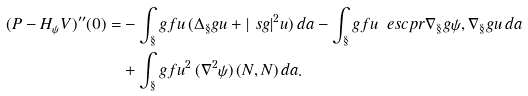Convert formula to latex. <formula><loc_0><loc_0><loc_500><loc_500>( P - H _ { \psi } V ) ^ { \prime \prime } ( 0 ) = & - \int _ { \S } g f u \, ( \Delta _ { \S } g u + | \ s g | ^ { 2 } u ) \, d a - \int _ { \S } g f u \, \ e s c p r { \nabla _ { \S } g \psi , \nabla _ { \S } g u } \, d a \\ & + \int _ { \S } g f u ^ { 2 } \, ( \nabla ^ { 2 } \psi ) \, ( N , N ) \, d a .</formula> 